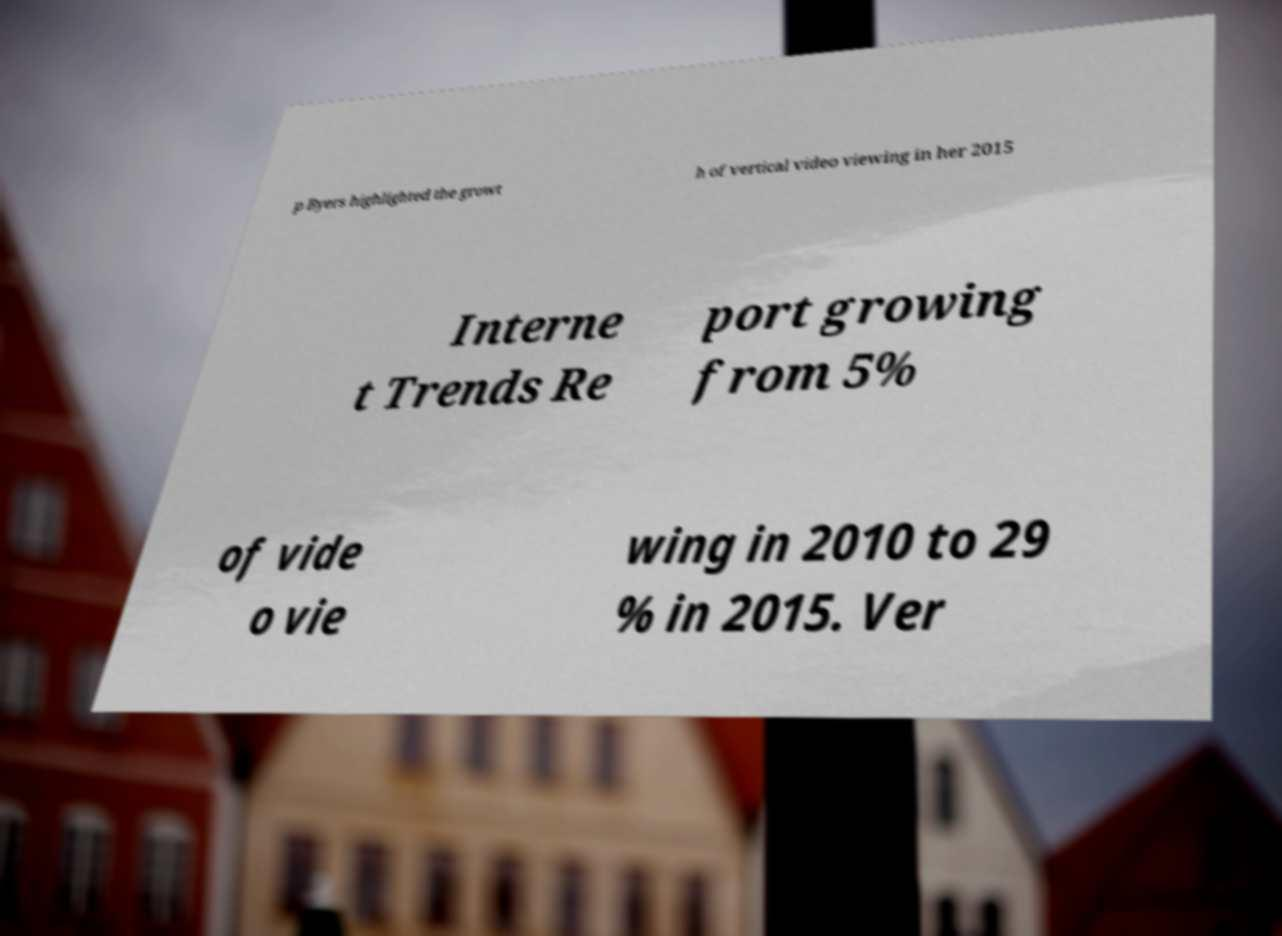Please identify and transcribe the text found in this image. p Byers highlighted the growt h of vertical video viewing in her 2015 Interne t Trends Re port growing from 5% of vide o vie wing in 2010 to 29 % in 2015. Ver 